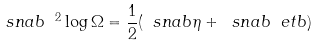<formula> <loc_0><loc_0><loc_500><loc_500>\ s n a b ^ { \ 2 } \log \Omega = \frac { 1 } { 2 } ( \ s n a b \eta + \ s n a b \ e t b )</formula> 